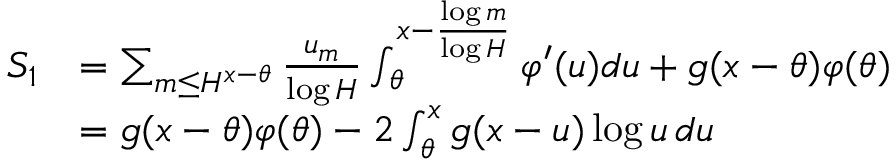Convert formula to latex. <formula><loc_0><loc_0><loc_500><loc_500>\begin{array} { r l } { S _ { 1 } } & { = \sum _ { m \leq H ^ { x - \theta } } \frac { u _ { m } } { \log H } \int _ { \theta } ^ { x - \frac { \log m } { \log H } } \varphi ^ { \prime } ( u ) d u + g ( x - \theta ) \varphi ( \theta ) } \\ & { = g ( x - \theta ) \varphi ( \theta ) - 2 \int _ { \theta } ^ { x } g ( x - u ) \log u \, d u } \end{array}</formula> 